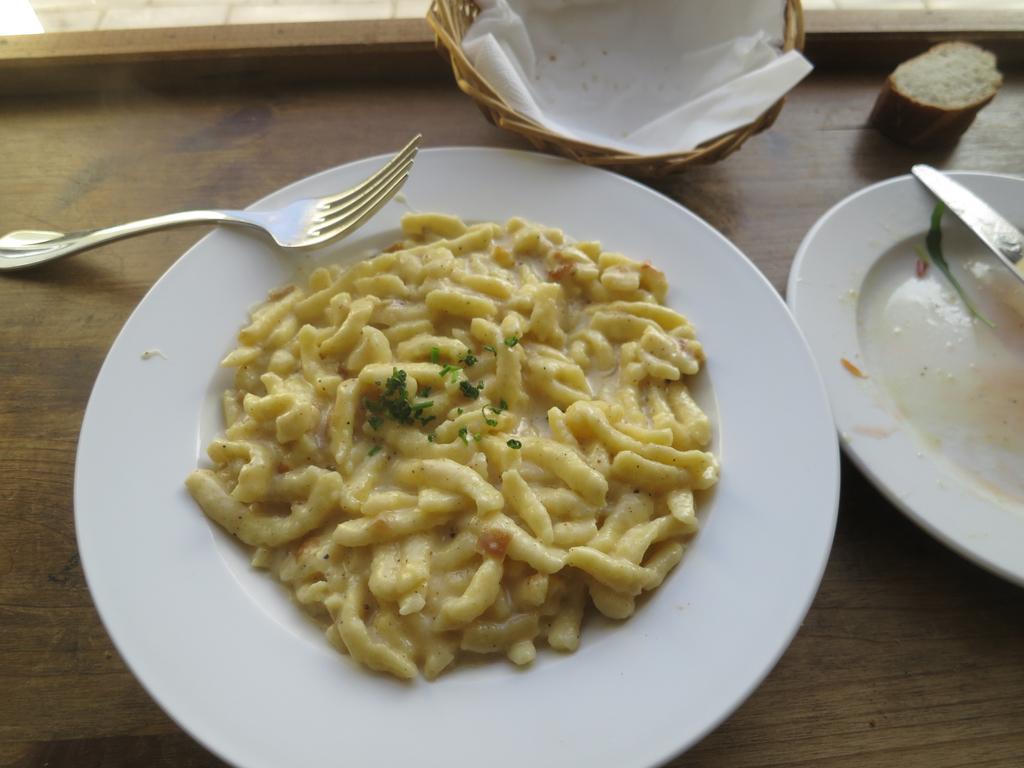How would you summarize this image in a sentence or two? In this image I can see food in the plate. The food is in cream and green color, I can also see a fork and knife, and the plate is on the table and the table is in brown color. 